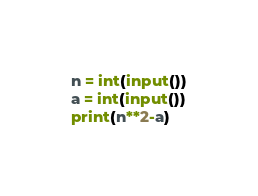Convert code to text. <code><loc_0><loc_0><loc_500><loc_500><_Python_>n = int(input())
a = int(input())
print(n**2-a)</code> 